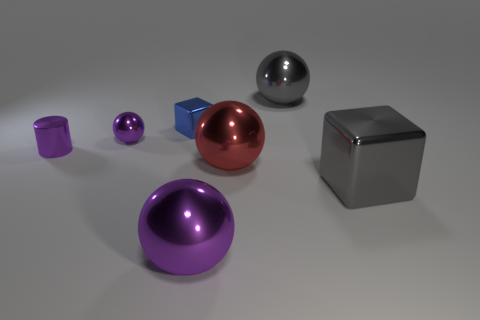Add 3 large red rubber objects. How many objects exist? 10 Subtract all blocks. How many objects are left? 5 Add 4 gray spheres. How many gray spheres exist? 5 Subtract 1 gray balls. How many objects are left? 6 Subtract all green cylinders. Subtract all large purple metal spheres. How many objects are left? 6 Add 3 big gray shiny cubes. How many big gray shiny cubes are left? 4 